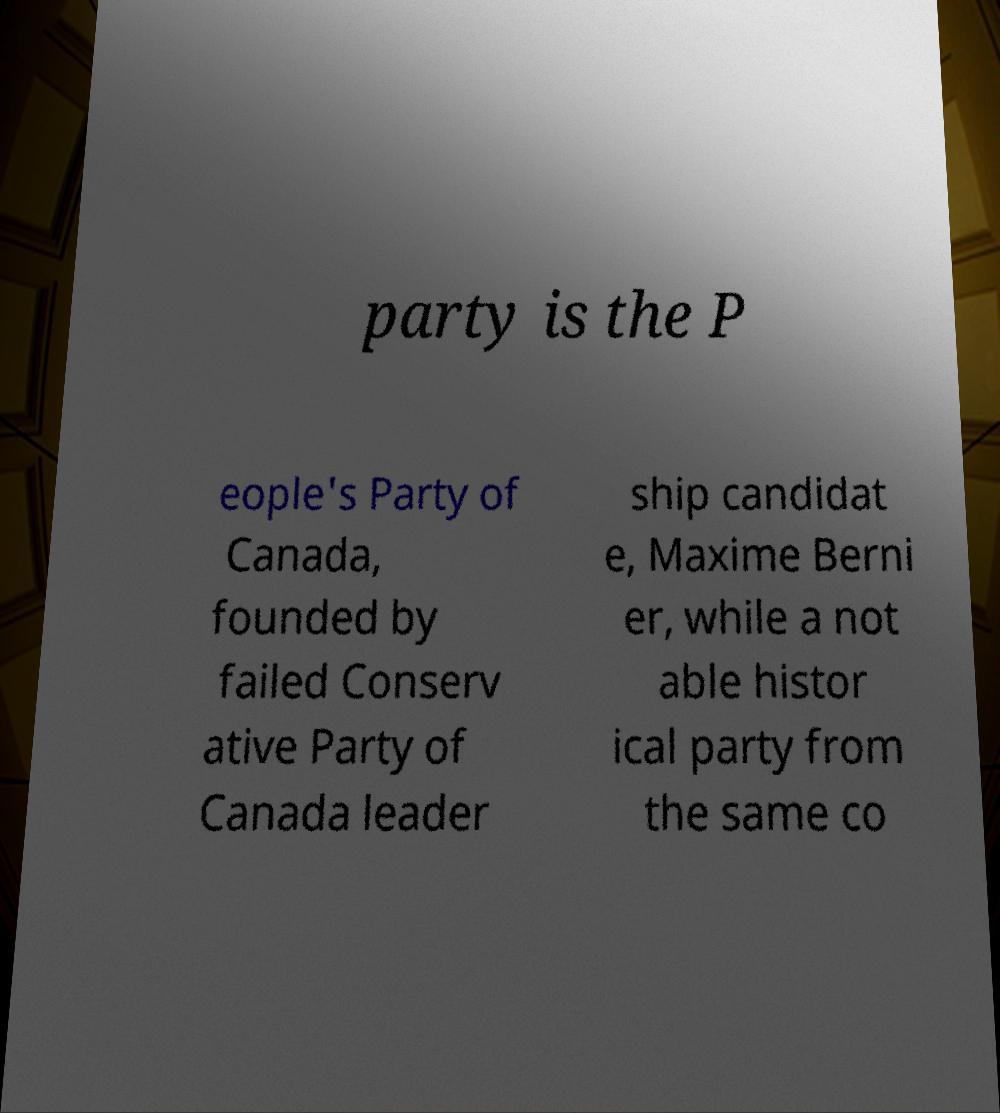Could you assist in decoding the text presented in this image and type it out clearly? party is the P eople's Party of Canada, founded by failed Conserv ative Party of Canada leader ship candidat e, Maxime Berni er, while a not able histor ical party from the same co 